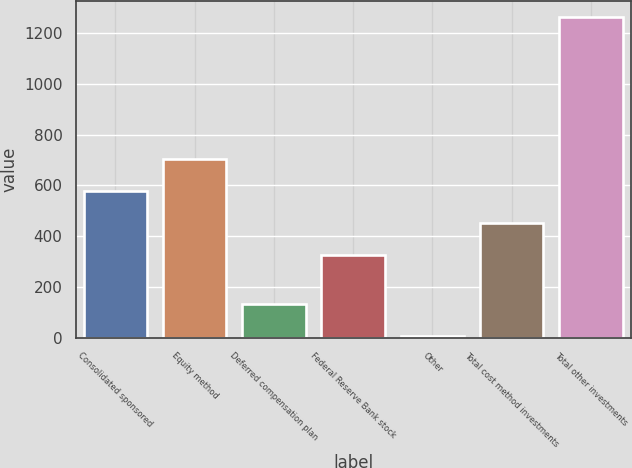Convert chart to OTSL. <chart><loc_0><loc_0><loc_500><loc_500><bar_chart><fcel>Consolidated sponsored<fcel>Equity method<fcel>Deferred compensation plan<fcel>Federal Reserve Bank stock<fcel>Other<fcel>Total cost method investments<fcel>Total other investments<nl><fcel>576.6<fcel>702.4<fcel>131.8<fcel>325<fcel>6<fcel>450.8<fcel>1264<nl></chart> 